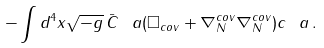Convert formula to latex. <formula><loc_0><loc_0><loc_500><loc_500>- \int d ^ { 4 } x \sqrt { - g } \, { \bar { C } } ^ { \ } a ( \square _ { c o v } + \nabla ^ { c o v } _ { N } \nabla ^ { c o v } _ { N } ) c ^ { \ } a \, .</formula> 